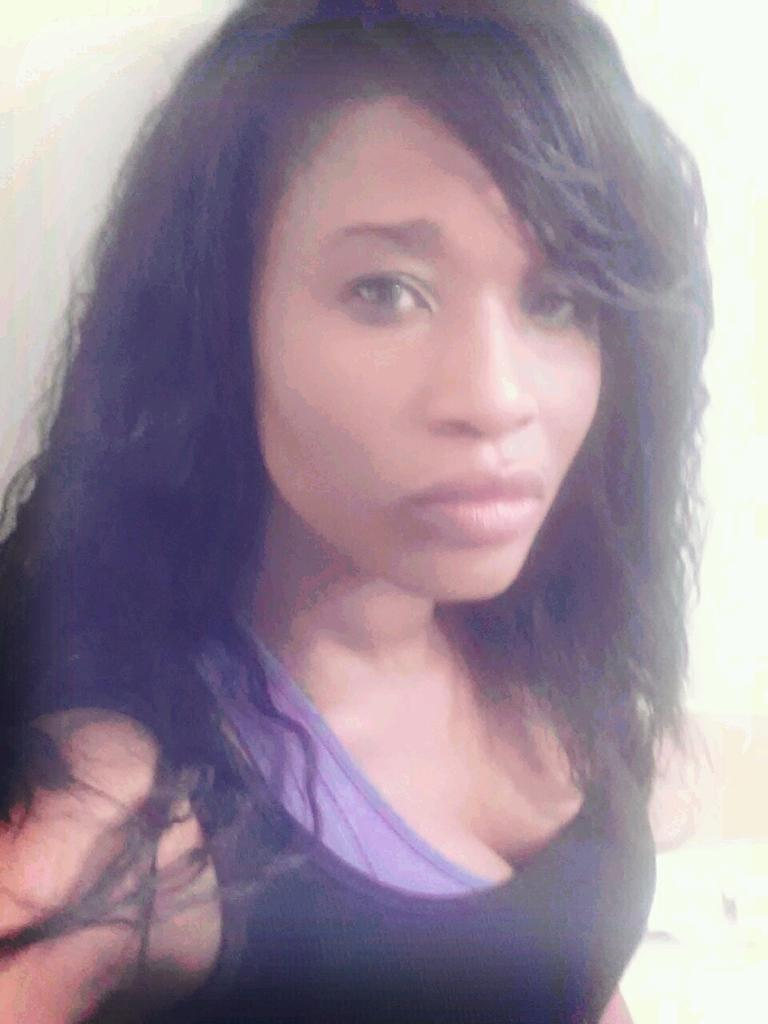Who is the main subject in the image? There is a woman in the image. What is the woman wearing? The woman is wearing a black T-shirt. What is the woman doing in the image? The woman is posing for the photo. What color is the background of the image? The background of the image is white in color. What type of oil is the woman using to run in the image? There is no mention of oil or running in the image; it features a woman posing for a photo with a white background. 